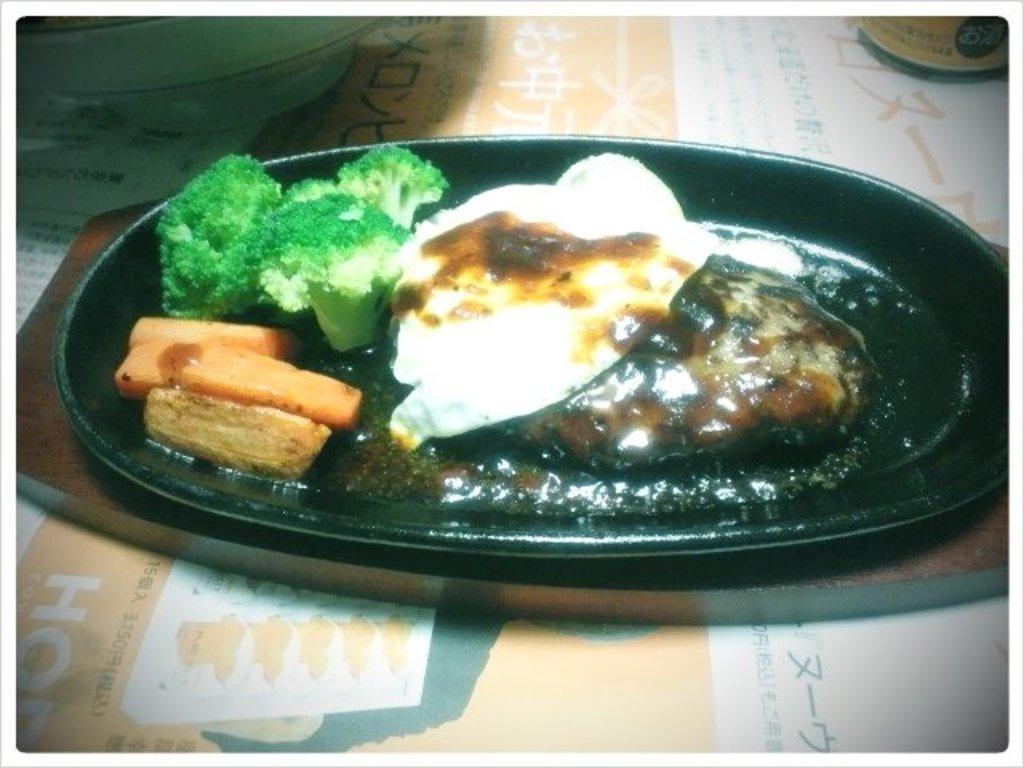How would you summarize this image in a sentence or two? In this image we can see the table with the text on it. We can also see the wooden object and on the object we can see the plate of food items. We can also see the bowl in the background. 